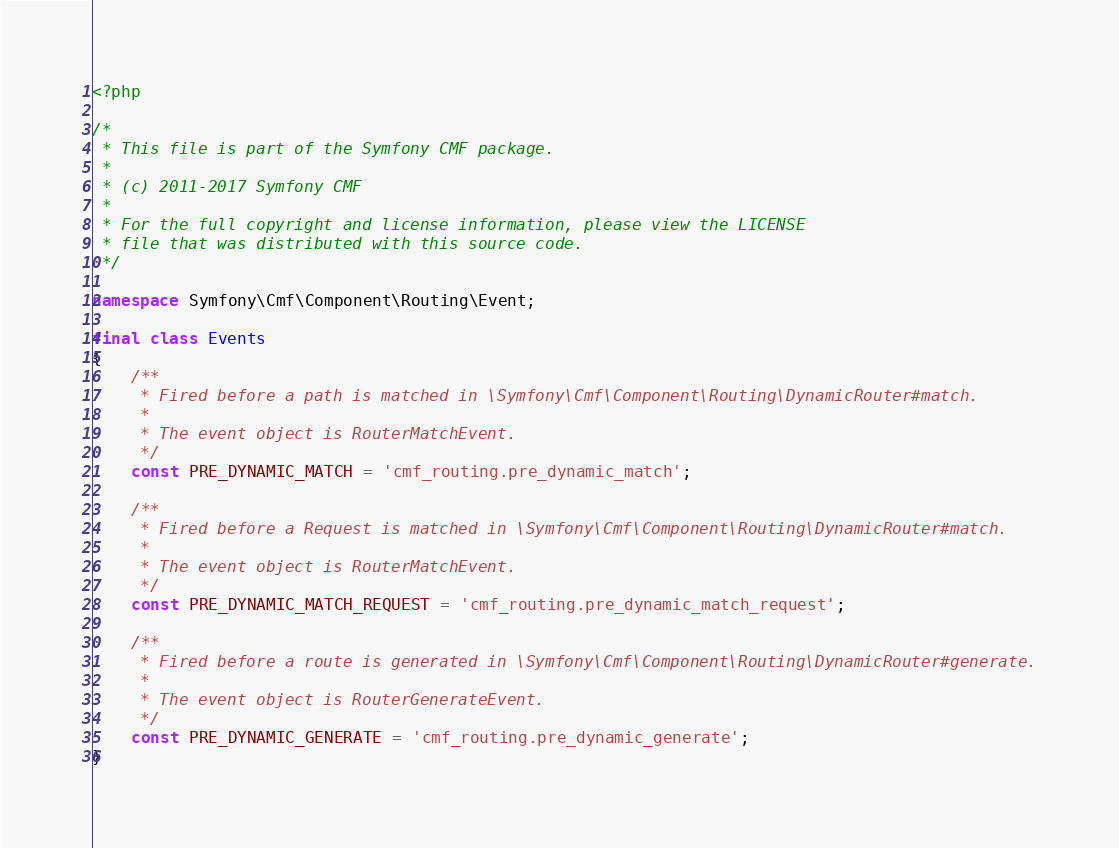Convert code to text. <code><loc_0><loc_0><loc_500><loc_500><_PHP_><?php

/*
 * This file is part of the Symfony CMF package.
 *
 * (c) 2011-2017 Symfony CMF
 *
 * For the full copyright and license information, please view the LICENSE
 * file that was distributed with this source code.
 */

namespace Symfony\Cmf\Component\Routing\Event;

final class Events
{
    /**
     * Fired before a path is matched in \Symfony\Cmf\Component\Routing\DynamicRouter#match.
     *
     * The event object is RouterMatchEvent.
     */
    const PRE_DYNAMIC_MATCH = 'cmf_routing.pre_dynamic_match';

    /**
     * Fired before a Request is matched in \Symfony\Cmf\Component\Routing\DynamicRouter#match.
     *
     * The event object is RouterMatchEvent.
     */
    const PRE_DYNAMIC_MATCH_REQUEST = 'cmf_routing.pre_dynamic_match_request';

    /**
     * Fired before a route is generated in \Symfony\Cmf\Component\Routing\DynamicRouter#generate.
     *
     * The event object is RouterGenerateEvent.
     */
    const PRE_DYNAMIC_GENERATE = 'cmf_routing.pre_dynamic_generate';
}
</code> 